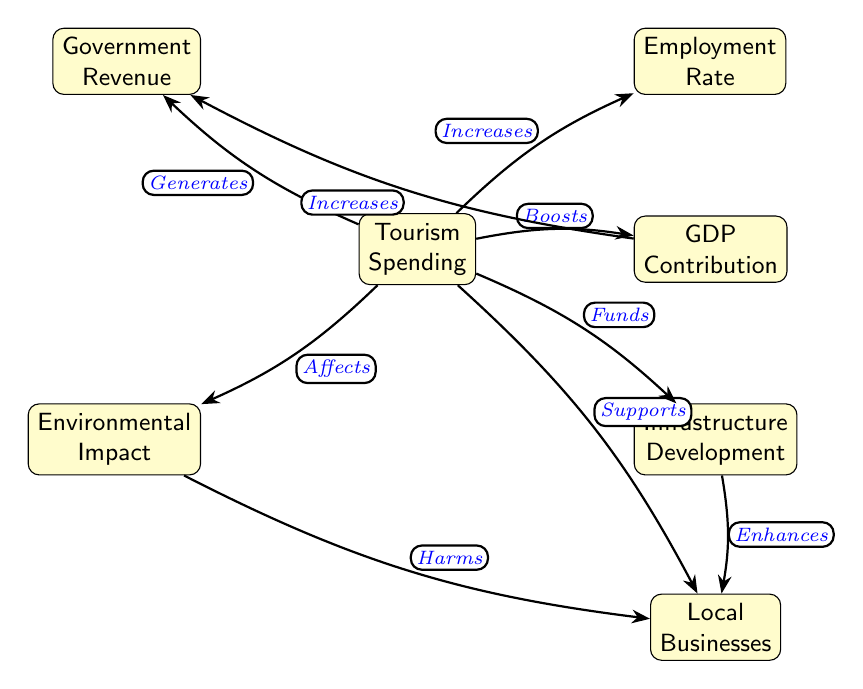What is the central node in the diagram? The central node is Tourism Spending, as it connects to several other elements that derive their relationships from it, indicating its importance in the context of the economic impact of tourism in Jamaica.
Answer: Tourism Spending How many nodes are present in the diagram? By counting the individual elements in the diagram, we identify a total of 7 nodes: Tourism Spending, Employment Rate, GDP Contribution, Infrastructure Development, Local Businesses, Environmental Impact, and Government Revenue.
Answer: 7 Which node is directly affected by both Tourism Spending and GDP Contribution? The node that is directly affected by both Tourism Spending and GDP Contribution is Government Revenue, as it receives influences from both these nodes according to the edges drawn in the diagram.
Answer: Government Revenue What effect does Tourism Spending have on Local Businesses? Tourism Spending supports Local Businesses, as indicated by the edge that connects these two nodes, showing a positive relationship in the flow of the diagram.
Answer: Supports How does Infrastructure Development influence Local Businesses? Infrastructure Development enhances Local Businesses according to the edge that connects these two nodes, which shows that improvements in infrastructure positively impact local economies.
Answer: Enhances What is the relationship between Environmental Impact and Local Businesses? The Environmental Impact node harms Local Businesses, as represented by the edge's direction and label in the diagram, which signifies a negative effect.
Answer: Harms Which node has two direct influences from other nodes? The node Government Revenue has two direct influences: one from Tourism Spending and another from GDP Contribution, demonstrating how it relies on multiple factors for its increase.
Answer: Government Revenue What increases the Employment Rate according to the diagram? The Employment Rate is increased by Tourism Spending, as indicated by the edge connecting the two nodes and the label "Increases," illustrating the positive impact of tourism on job creation.
Answer: Increases Which node has a direct negative effect on Local Businesses? The Environmental Impact node has a direct negative effect on Local Businesses, as shown by the edge that specifies "Harms" in the relationship connecting these two nodes.
Answer: Environmental Impact 